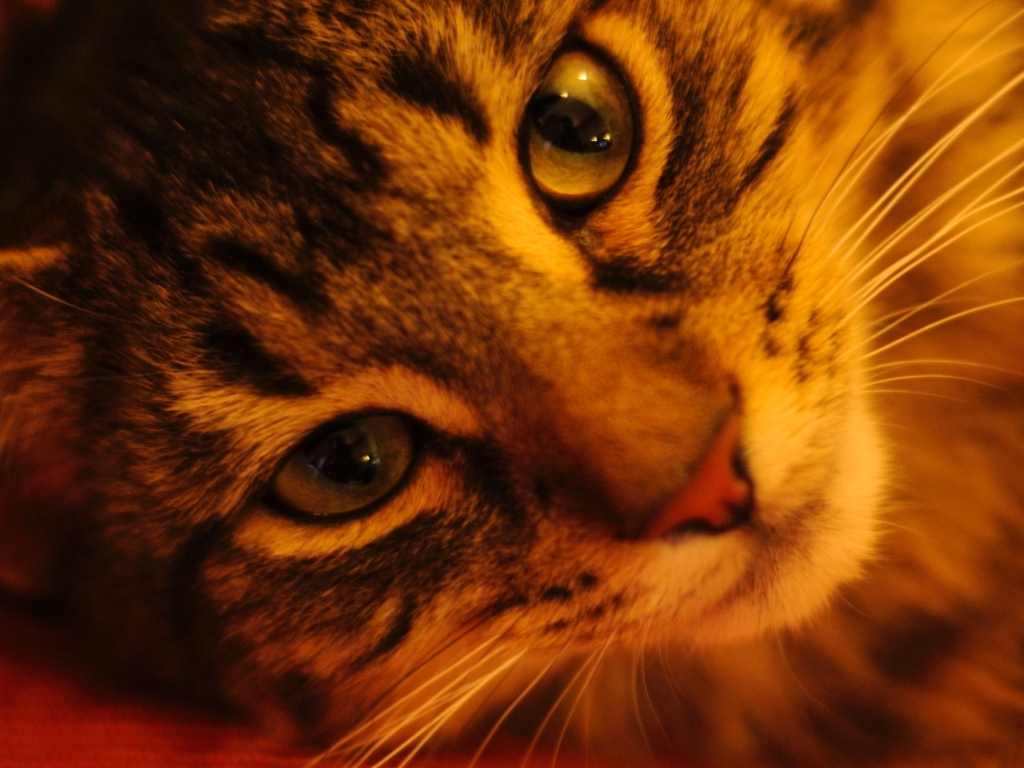Can you describe the lighting in the image? The image has a warm, ambient light that highlights the left side of the cat's face, illuminating its eyes and enhancing the feline’s features against the darker, more shadowed background. 